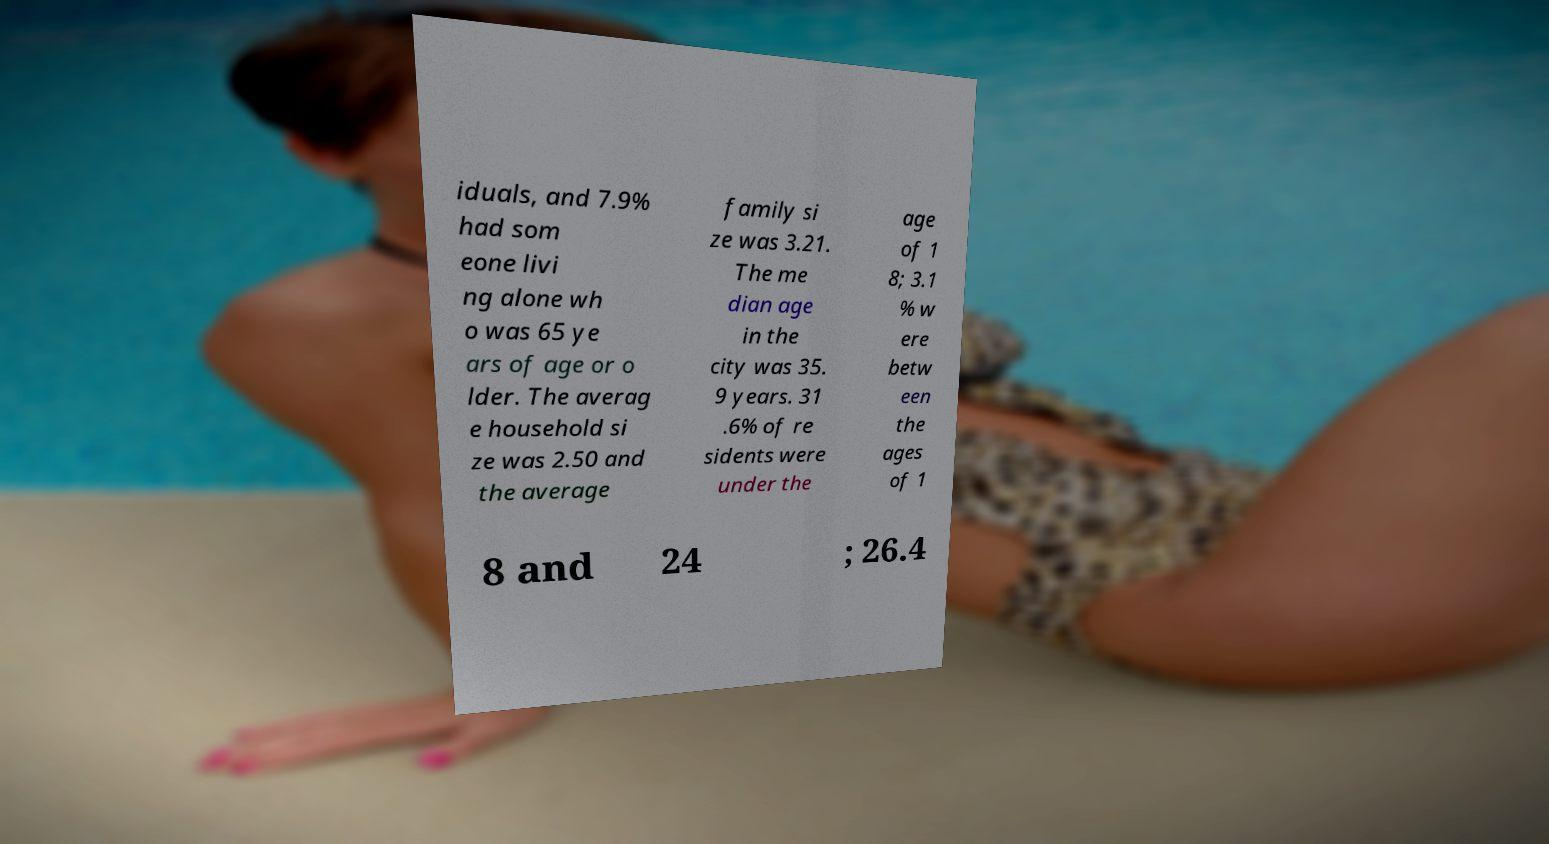Please identify and transcribe the text found in this image. iduals, and 7.9% had som eone livi ng alone wh o was 65 ye ars of age or o lder. The averag e household si ze was 2.50 and the average family si ze was 3.21. The me dian age in the city was 35. 9 years. 31 .6% of re sidents were under the age of 1 8; 3.1 % w ere betw een the ages of 1 8 and 24 ; 26.4 